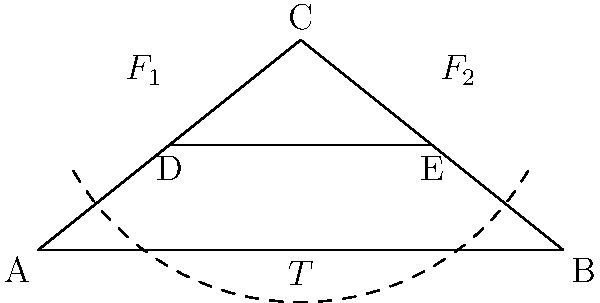In the stone arch bridge design shown above, inspired by the iconic Stari Most in Mostar, what is the primary force that ensures the structural integrity of the arch, and how does it relate to the horizontal thrust at the abutments? Express your answer in terms of the forces $F_1$ and $F_2$, and the horizontal thrust $T$. To understand the structural integrity of the stone arch bridge, we need to follow these steps:

1. Identify the main forces acting on the arch:
   - $F_1$ and $F_2$ are the vertical loads (weight of the arch and any additional loads)
   - $T$ is the horizontal thrust at the abutments (points A and B)

2. Understand the arch's behavior:
   The arch works by transferring the vertical loads ($F_1$ and $F_2$) into a compressive force along the curve of the arch.

3. Analyze the force balance:
   For the arch to be in equilibrium, the horizontal thrust $T$ at the abutments must balance the horizontal component of the compressive force in the arch.

4. Consider the relationship between vertical loads and horizontal thrust:
   The magnitude of $T$ is directly related to the vertical loads $F_1$ and $F_2$. As the vertical loads increase, so does the horizontal thrust.

5. Express the relationship mathematically:
   The horizontal thrust $T$ can be approximated as:
   
   $$ T \approx \frac{(F_1 + F_2) \cdot L}{8h} $$
   
   Where $L$ is the span of the arch and $h$ is the rise of the arch.

6. Identify the primary force for structural integrity:
   The compressive force along the arch, resulting from the combination of vertical loads and horizontal thrust, is the primary force ensuring the arch's stability.

7. Conclude:
   The primary force ensuring structural integrity is the compressive force along the arch, which is a result of the vertical loads ($F_1$ and $F_2$) being resisted by the horizontal thrust ($T$) at the abutments.
Answer: Compressive force along the arch, resulting from $F_1$, $F_2$, and $T$ 